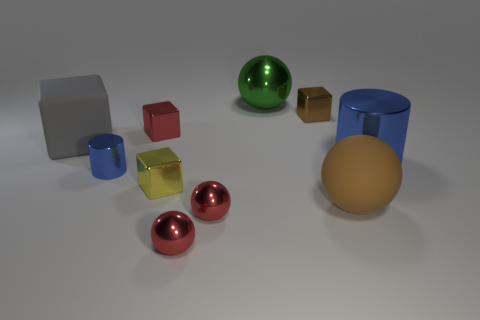What number of blue objects are cubes or big spheres?
Your answer should be compact. 0. There is a metal block that is the same color as the rubber sphere; what size is it?
Provide a short and direct response. Small. Is the number of big blue rubber blocks greater than the number of large gray blocks?
Your answer should be compact. No. Does the large cylinder have the same color as the tiny cylinder?
Your answer should be very brief. Yes. What number of objects are blue cubes or red metal things that are in front of the big gray cube?
Provide a succinct answer. 2. How many other things are there of the same shape as the big brown thing?
Provide a short and direct response. 3. Is the number of brown metallic things behind the large brown thing less than the number of gray things that are in front of the tiny cylinder?
Provide a short and direct response. No. Are there any other things that have the same material as the brown ball?
Offer a terse response. Yes. The other thing that is made of the same material as the large gray thing is what shape?
Offer a terse response. Sphere. Are there any other things of the same color as the big matte block?
Make the answer very short. No. 